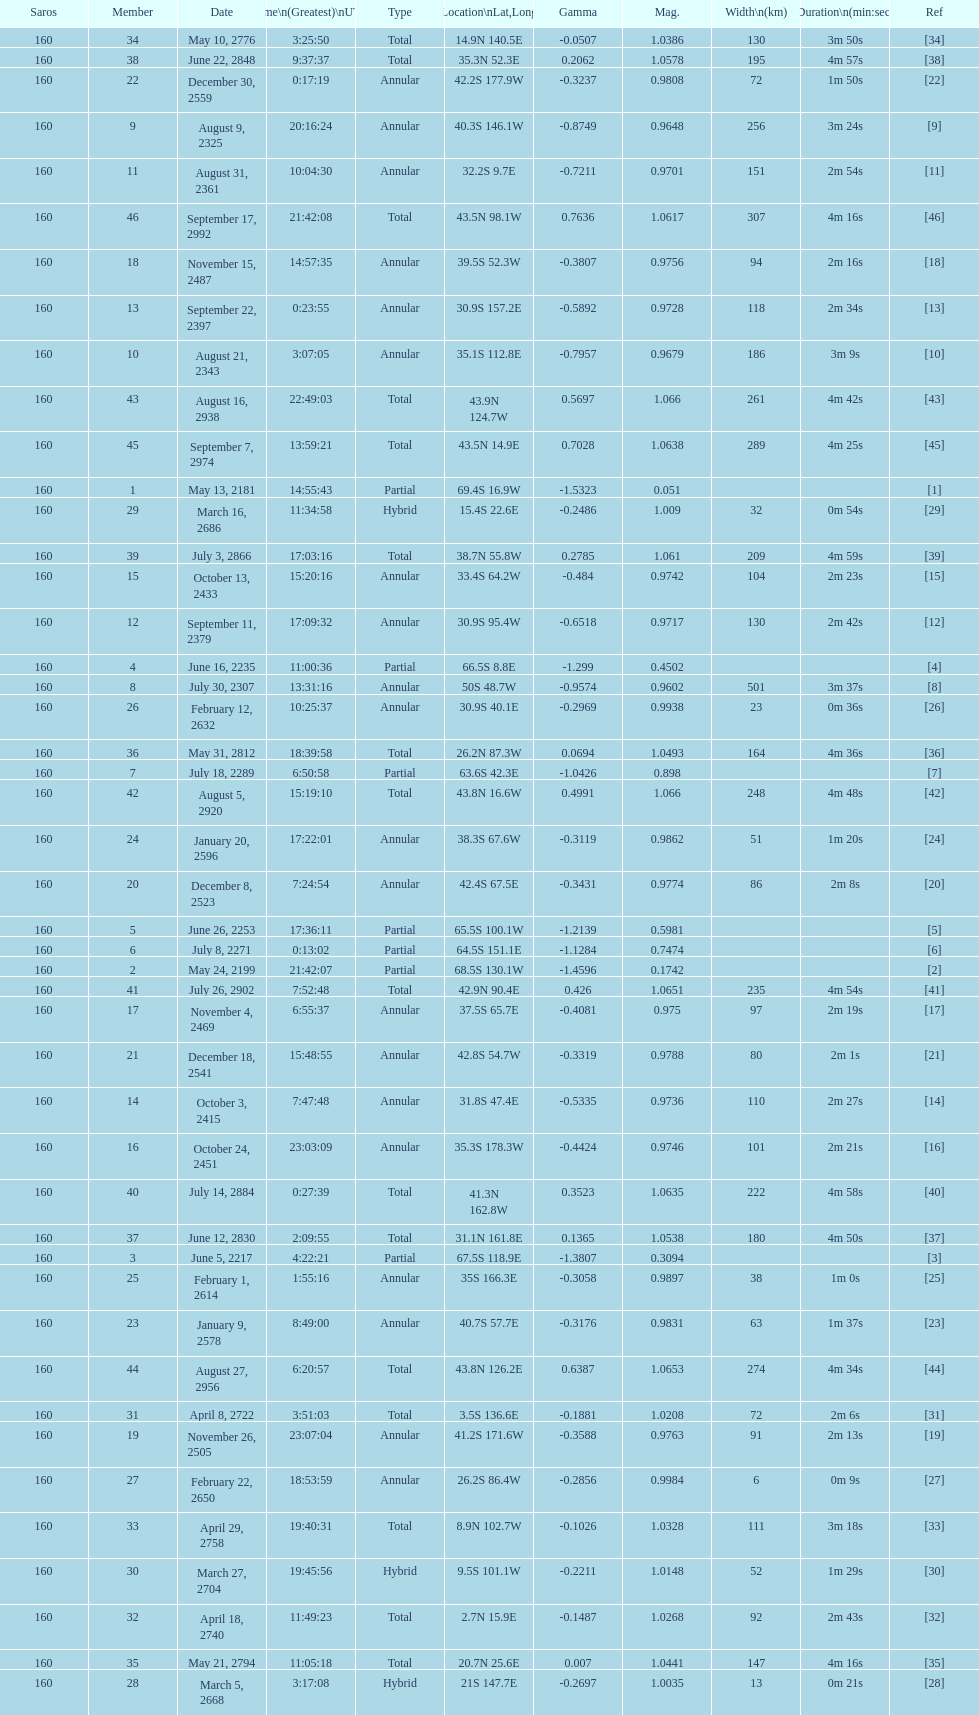How many solar saros events lasted longer than 4 minutes? 12. 